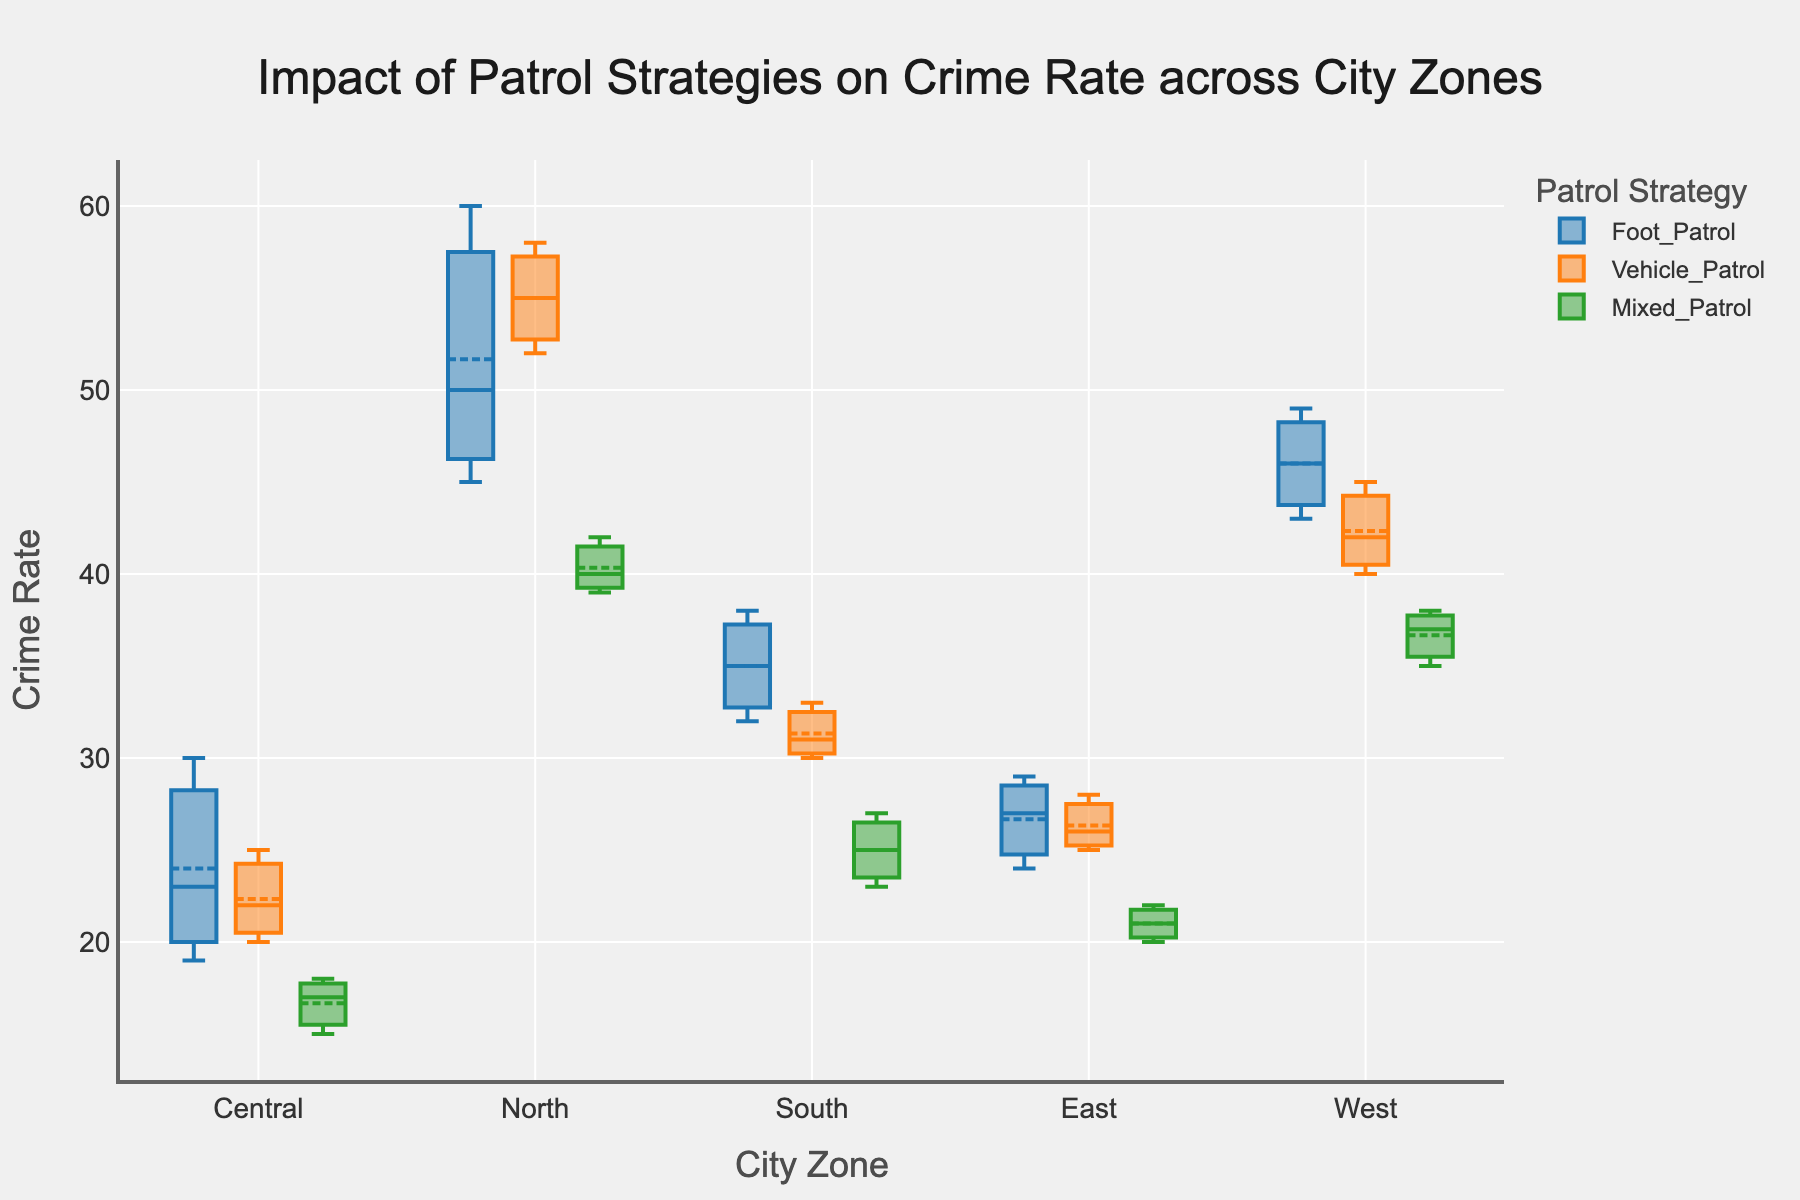What is the title of the box plot? The title is displayed at the top center of the plot. It helps understand the context of the graph.
Answer: Impact of Patrol Strategies on Crime Rate across City Zones What are the city zones shown on the x-axis? The city zones are listed along the x-axis at the bottom of the plot. They represent different zones where data has been collected.
Answer: Central, North, South, East, West Which patrol strategy shows the lowest average crime rate in the Central zone? The average crime rate can be identified by looking at the mean marker within the box plot for each patrol strategy. The one with the lowest position has the lowest average crime rate.
Answer: Mixed_Patrol In the North zone, which patrol strategy has the highest maximum crime rate? Looking at the upper whisker of each box plot in the North zone, the strategy with the highest whisker represents the highest maximum crime rate.
Answer: Foot_Patrol How does the crime rate for Vehicle_Patrol in the Central zone compare to Vehicle_Patrol in the South zone? By comparing the median lines or the entirety of the box plots for Vehicle_Patrol in both Central and South zones, one can see the differences in crime rates.
Answer: Higher in Central Which zone shows the highest median crime rate for Mixed_Patrol? The median line within each box plot represents the median crime rate. The zone with the highest median line among the Mixed_Patrol box plots shows the highest median.
Answer: North What is the range of crime rates for Foot_Patrol in the East zone? The range is determined by the position of the bottom and top whiskers of the Foot_Patrol box plot in the East zone. The whiskers indicate the minimum and maximum values.
Answer: 24 to 29 Which patrol strategy generally shows the most consistency in crime rates across all zones? Consistency can be identified by looking at the spread of the boxes and whiskers: smaller spreads indicate more consistency.
Answer: Mixed_Patrol In which zone do all patrol strategies have overlapping crime rate ranges? Overlapping ranges can be seen by the extent of the whiskers and boxes. If all patrol strategies' boxes and whiskers in a particular zone overlap, this is the desired zone.
Answer: Central 